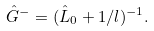Convert formula to latex. <formula><loc_0><loc_0><loc_500><loc_500>\hat { G } ^ { - } = ( \hat { L } _ { 0 } + 1 / l ) ^ { - 1 } .</formula> 